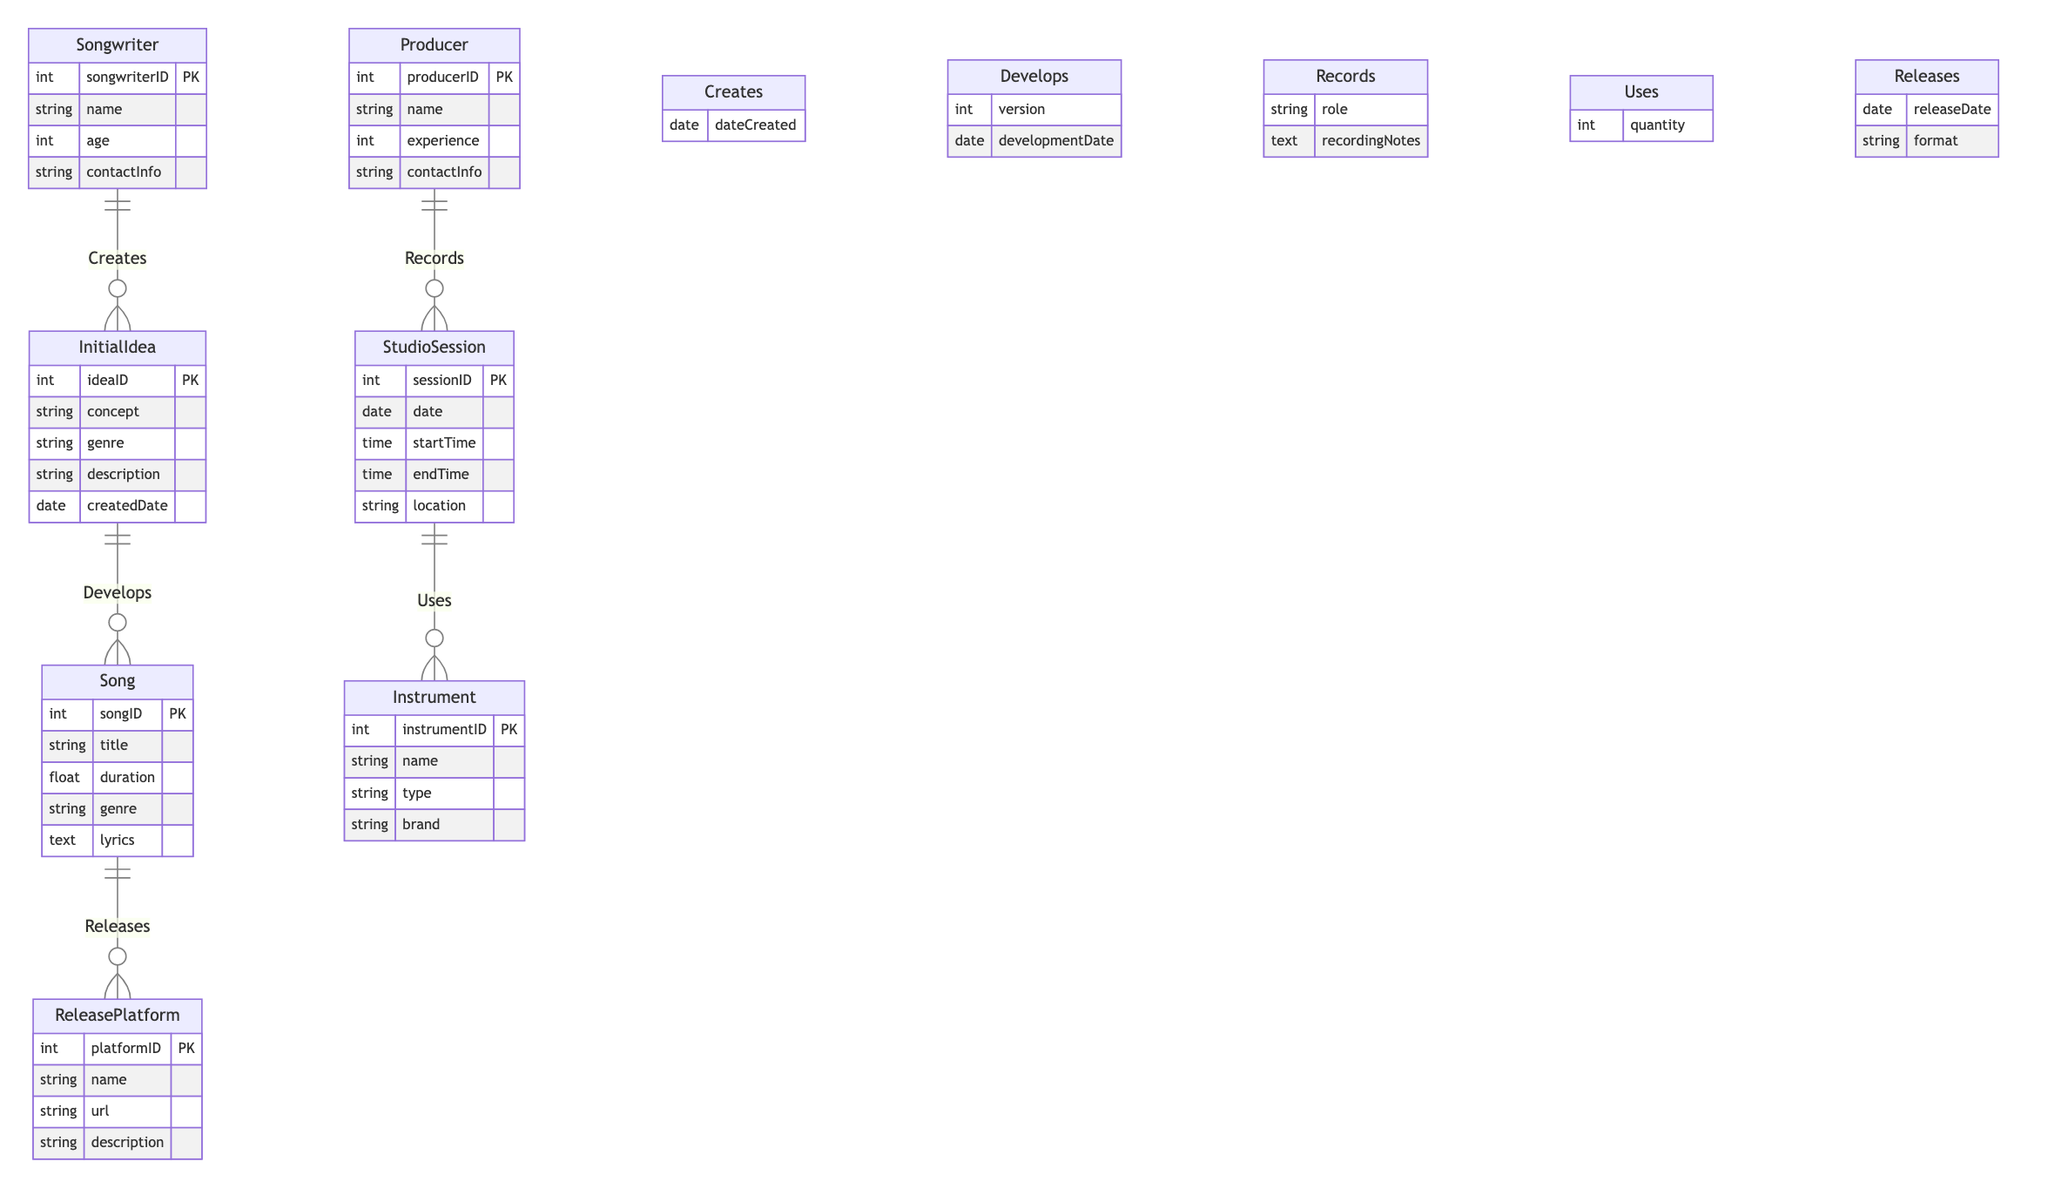What is the primary entity that represents a concept for a music album? The primary entity that represents a concept for a music album is "InitialIdea," as it encompasses attributes like concept, genre, and description.
Answer: InitialIdea How many musician roles are listed in the diagram? There are two main roles involving musicians: "Songwriter" and "Producer," as evident from their separate entities in the diagram.
Answer: 2 Which entity is responsible for developing songs from initial ideas? The "Song" entity is developed from the "InitialIdea," indicating a direct relationship where songs are created based on these initial concepts.
Answer: Song What relationship connects songwriters and initial ideas? The relationship that connects songwriters and initial ideas is called "Creates," indicating that songwriters generate initial ideas for music.
Answer: Creates What attribute is associated with the relationship that connects producers and studio sessions? The attribute associated with the relationship connecting producers and studio sessions is "role," detailing the specific responsibility of the producer during sessions.
Answer: role Which platform is the final step before releasing a song? The "ReleasePlatform" is the entity where songs are officially released, representing the final stage in the music production process.
Answer: ReleasePlatform What is the maximum number of instruments that can be used in a studio session according to the diagram? The maximum number of instruments is not explicitly defined in the diagram; the "Uses" relationship includes an attribute for "quantity," indicating it can vary.
Answer: Not defined What is the main link between songs and their release formats? The main link between songs and their release formats is the "Releases" relationship, which details how and when a song is distributed on various platforms.
Answer: Releases What date-related attribute does the 'Develops' relationship include? The 'Develops' relationship includes the attribute "developmentDate," which tracks when a song is developed from its initial idea.
Answer: developmentDate 